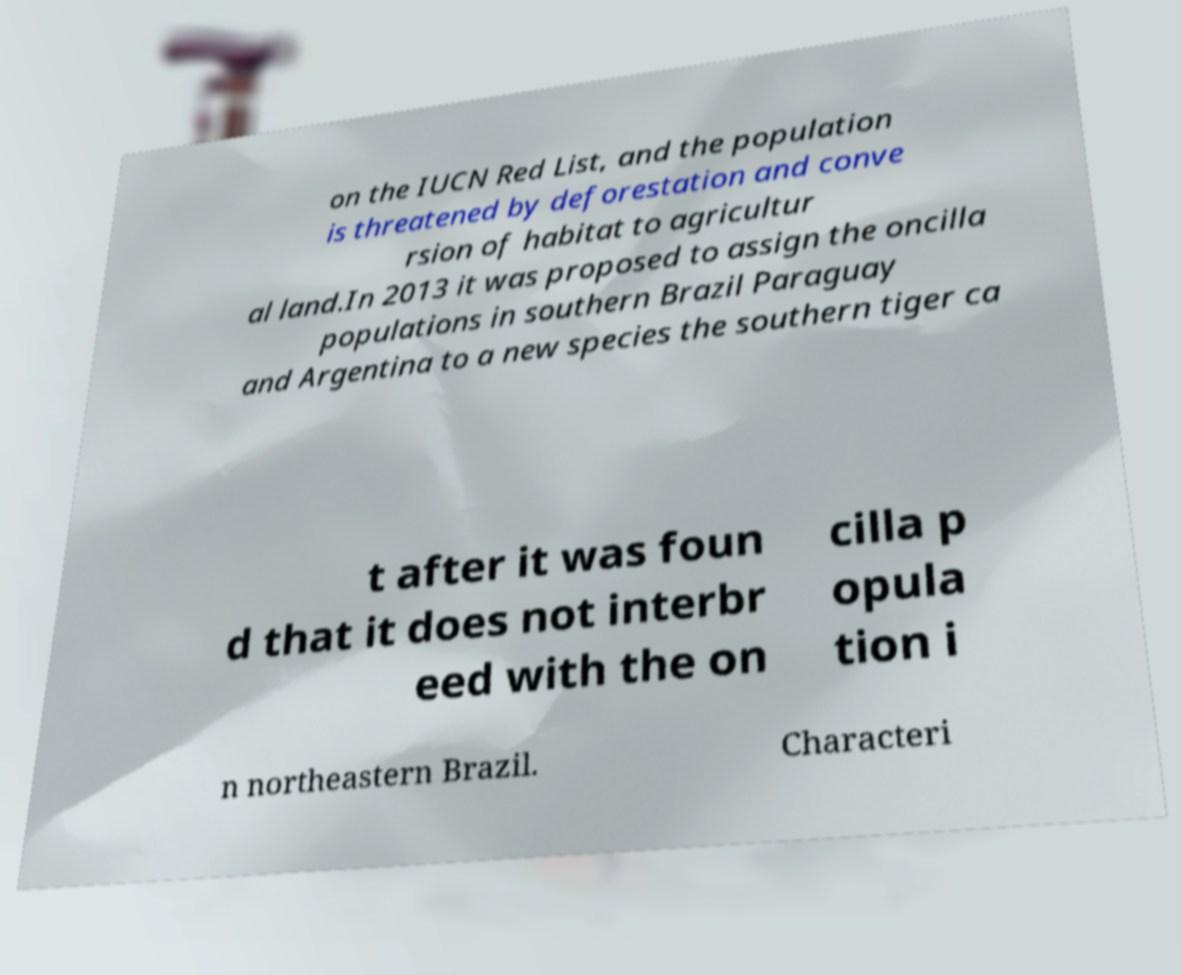I need the written content from this picture converted into text. Can you do that? on the IUCN Red List, and the population is threatened by deforestation and conve rsion of habitat to agricultur al land.In 2013 it was proposed to assign the oncilla populations in southern Brazil Paraguay and Argentina to a new species the southern tiger ca t after it was foun d that it does not interbr eed with the on cilla p opula tion i n northeastern Brazil. Characteri 